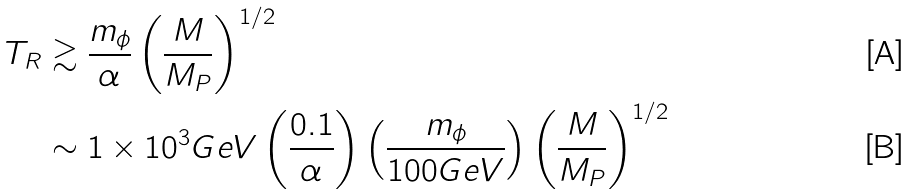Convert formula to latex. <formula><loc_0><loc_0><loc_500><loc_500>T _ { R } & \gtrsim \frac { m _ { \phi } } { \alpha } \left ( \frac { M } { M _ { P } } \right ) ^ { 1 / 2 } \\ & \sim 1 \times 1 0 ^ { 3 } G e V \left ( \frac { 0 . 1 } { \alpha } \right ) \left ( \frac { m _ { \phi } } { 1 0 0 G e V } \right ) \left ( \frac { M } { M _ { P } } \right ) ^ { 1 / 2 }</formula> 